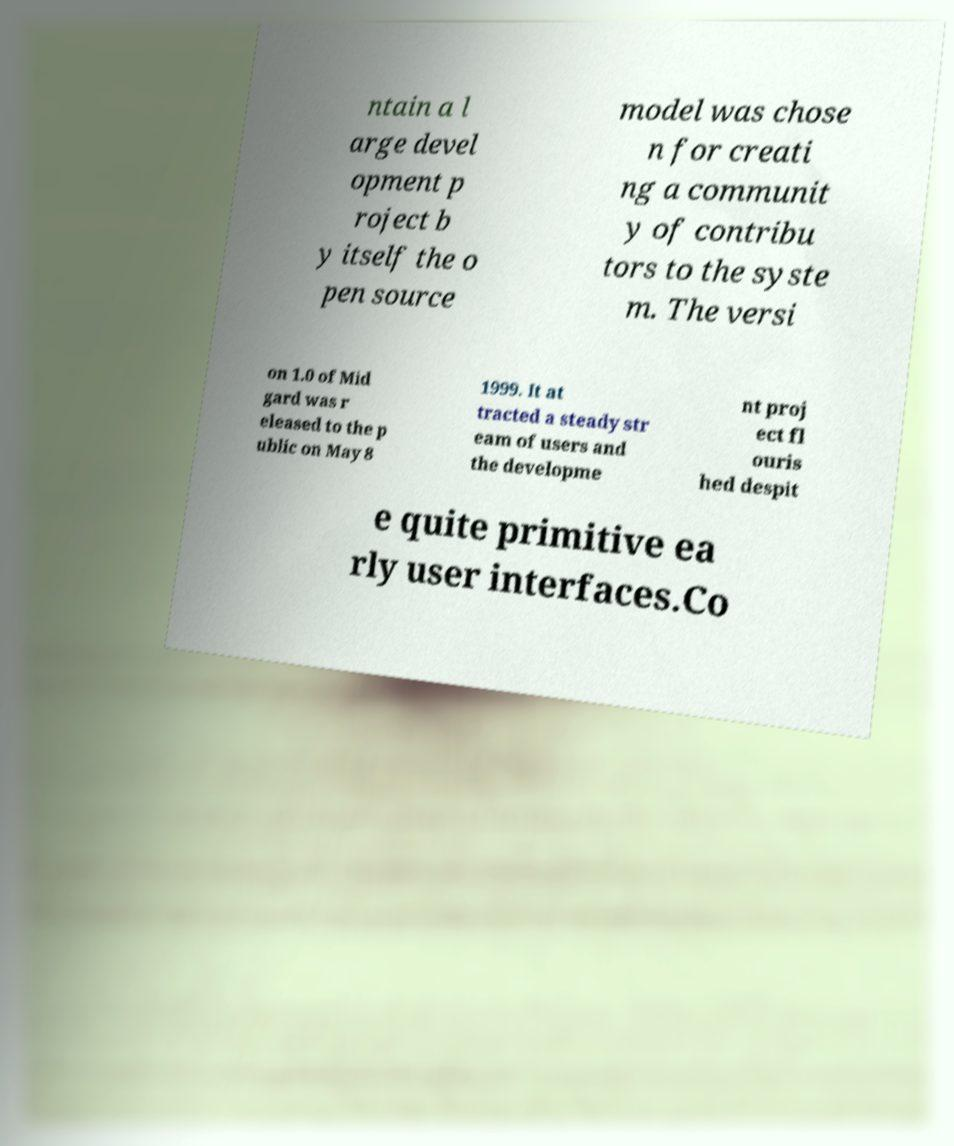Could you extract and type out the text from this image? ntain a l arge devel opment p roject b y itself the o pen source model was chose n for creati ng a communit y of contribu tors to the syste m. The versi on 1.0 of Mid gard was r eleased to the p ublic on May 8 1999. It at tracted a steady str eam of users and the developme nt proj ect fl ouris hed despit e quite primitive ea rly user interfaces.Co 